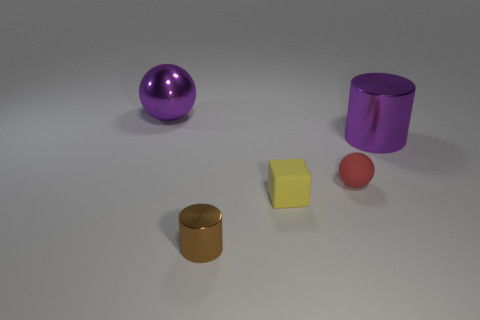There is a tiny thing that is both behind the tiny brown shiny thing and on the left side of the small sphere; what is its material?
Keep it short and to the point. Rubber. What shape is the tiny yellow object that is made of the same material as the small red object?
Give a very brief answer. Cube. There is a sphere that is made of the same material as the brown cylinder; what size is it?
Provide a succinct answer. Large. The thing that is both left of the small red ball and on the right side of the brown object has what shape?
Your answer should be very brief. Cube. There is a sphere right of the big purple thing on the left side of the purple cylinder; how big is it?
Offer a terse response. Small. How many other objects are there of the same color as the large shiny cylinder?
Your answer should be compact. 1. What material is the big purple cylinder?
Provide a succinct answer. Metal. Is there a red sphere?
Your response must be concise. Yes. Are there an equal number of objects left of the tiny rubber cube and large purple objects?
Provide a short and direct response. Yes. How many tiny objects are either purple metallic balls or balls?
Your answer should be compact. 1. 